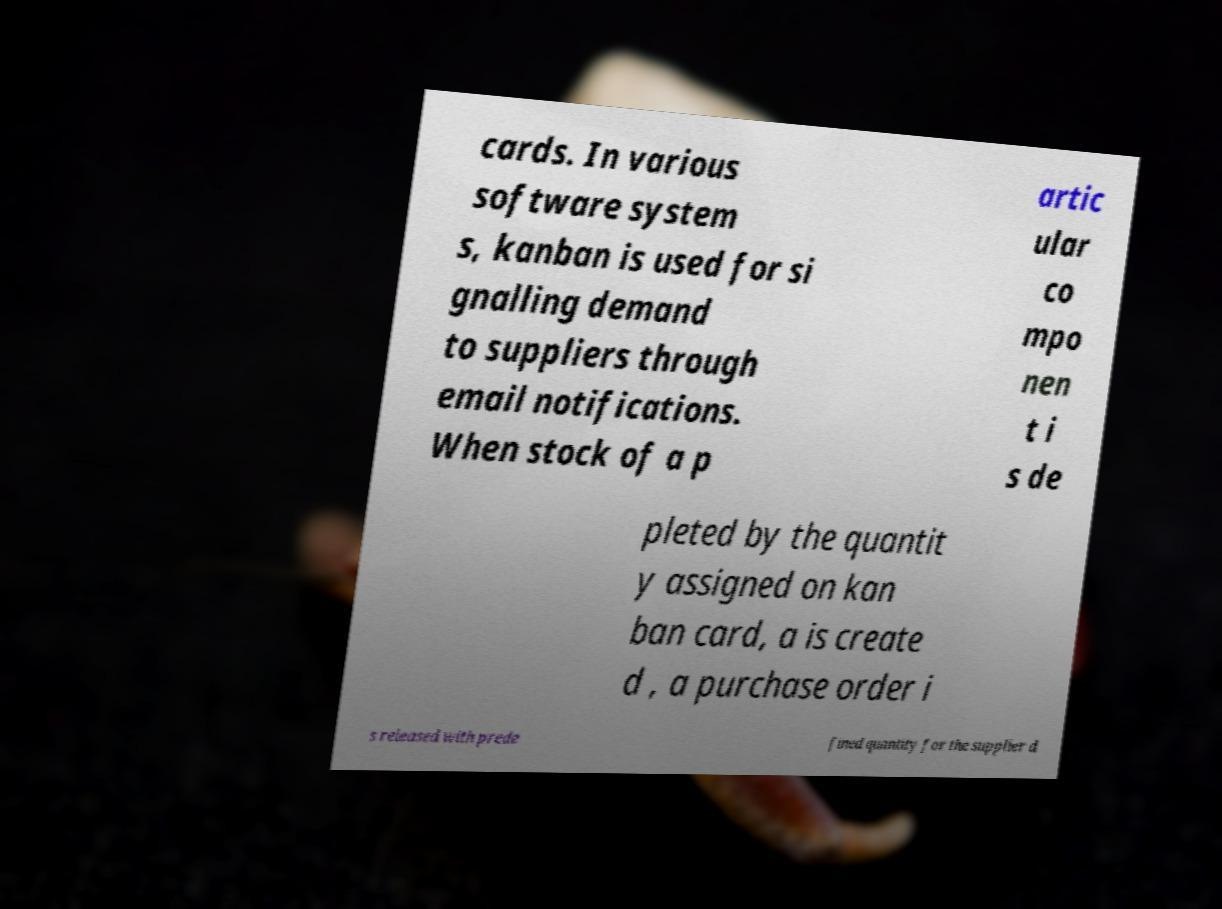Could you assist in decoding the text presented in this image and type it out clearly? cards. In various software system s, kanban is used for si gnalling demand to suppliers through email notifications. When stock of a p artic ular co mpo nen t i s de pleted by the quantit y assigned on kan ban card, a is create d , a purchase order i s released with prede fined quantity for the supplier d 